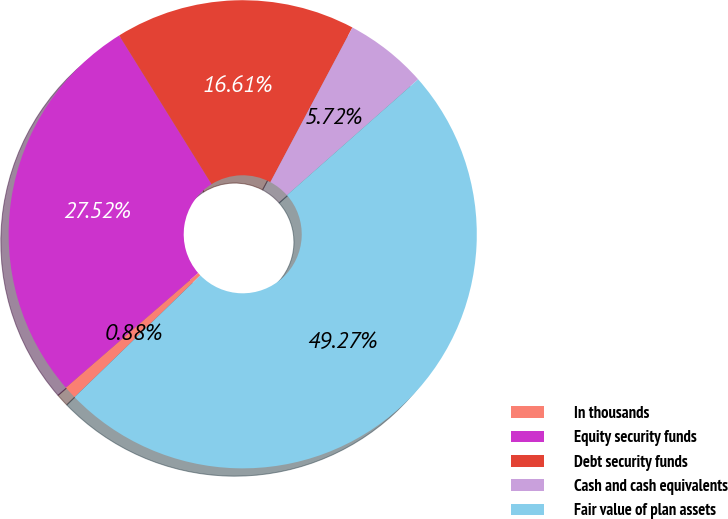<chart> <loc_0><loc_0><loc_500><loc_500><pie_chart><fcel>In thousands<fcel>Equity security funds<fcel>Debt security funds<fcel>Cash and cash equivalents<fcel>Fair value of plan assets<nl><fcel>0.88%<fcel>27.52%<fcel>16.61%<fcel>5.72%<fcel>49.27%<nl></chart> 